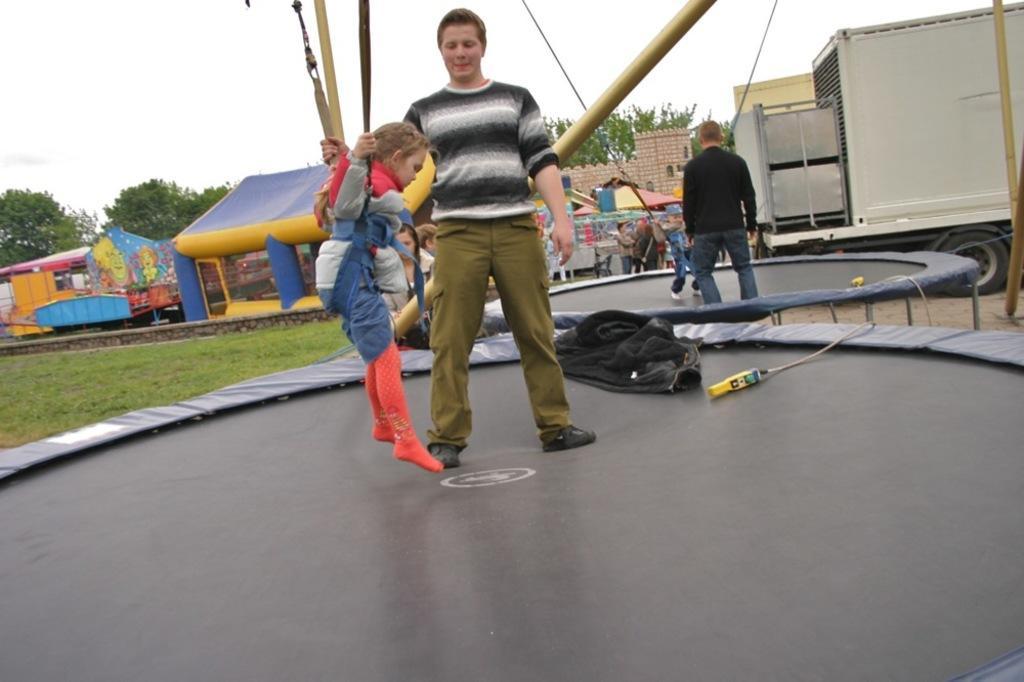Could you give a brief overview of what you see in this image? In this image we can see a few people, some of them are on the mini bungee trampoline, two kids are hung with the help of ropes, there are trees, there is a vehicle, there are bouncy castles and a house, also we can see the sky. 